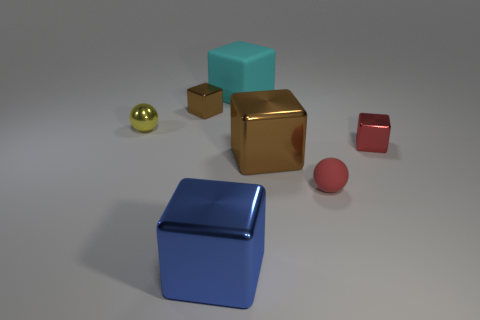Subtract all brown cubes. How many cubes are left? 3 Add 1 large cyan things. How many objects exist? 8 Subtract all blocks. How many objects are left? 2 Subtract all brown cylinders. How many brown cubes are left? 2 Subtract all red spheres. How many spheres are left? 1 Subtract all large matte cubes. Subtract all small red shiny blocks. How many objects are left? 5 Add 6 red cubes. How many red cubes are left? 7 Add 5 small brown things. How many small brown things exist? 6 Subtract 0 gray cubes. How many objects are left? 7 Subtract 2 balls. How many balls are left? 0 